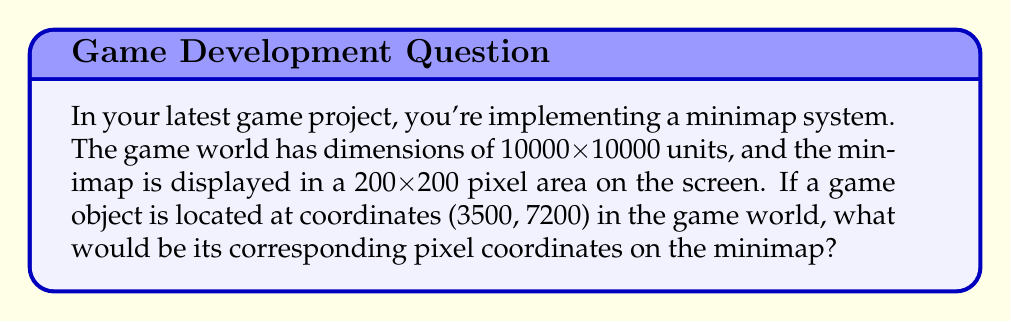Give your solution to this math problem. To solve this problem, we need to scale down the game world coordinates to fit the minimap dimensions. Here's a step-by-step approach:

1. Determine the scale factor:
   The scale factor is the ratio of minimap size to game world size.
   $$\text{Scale factor} = \frac{\text{Minimap size}}{\text{Game world size}} = \frac{200}{10000} = \frac{1}{50}$$

2. Scale down the object's coordinates:
   We multiply each coordinate by the scale factor to get the minimap coordinates.

   For x-coordinate:
   $$x_{\text{minimap}} = x_{\text{game}} \times \text{Scale factor}$$
   $$x_{\text{minimap}} = 3500 \times \frac{1}{50} = 70$$

   For y-coordinate:
   $$y_{\text{minimap}} = y_{\text{game}} \times \text{Scale factor}$$
   $$y_{\text{minimap}} = 7200 \times \frac{1}{50} = 144$$

3. Adjust y-coordinate:
   Since computer graphics typically have the origin at the top-left corner with y-axis pointing downwards, we need to invert the y-coordinate:
   $$y_{\text{minimap}} = 200 - 144 = 56$$

Therefore, the object's coordinates on the 200x200 pixel minimap would be (70, 56).
Answer: (70, 56) 